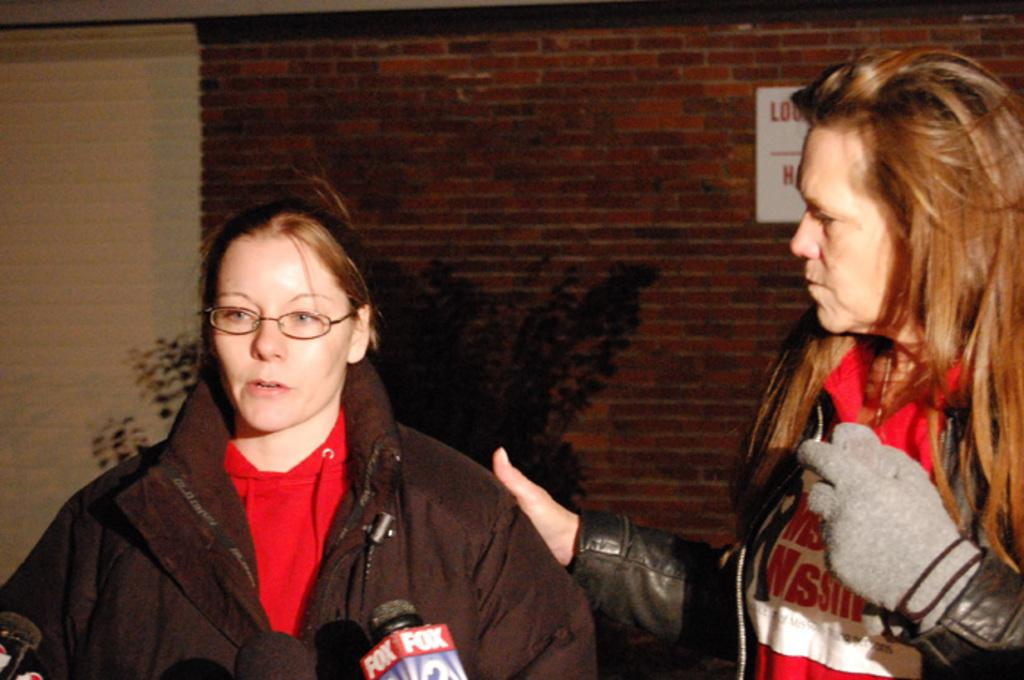How many people are in the foreground of the image? There are two ladies in the foreground of the image. What are the ladies wearing? The ladies are wearing jackets. What can be seen in the background of the image? There is a wall in the background of the image. Are there any plants visible in the image? Yes, there is a plant in the image. What type of pig can be seen in the image? There is no pig present in the image. Is there any smoke visible in the image? There is no smoke visible in the image. 